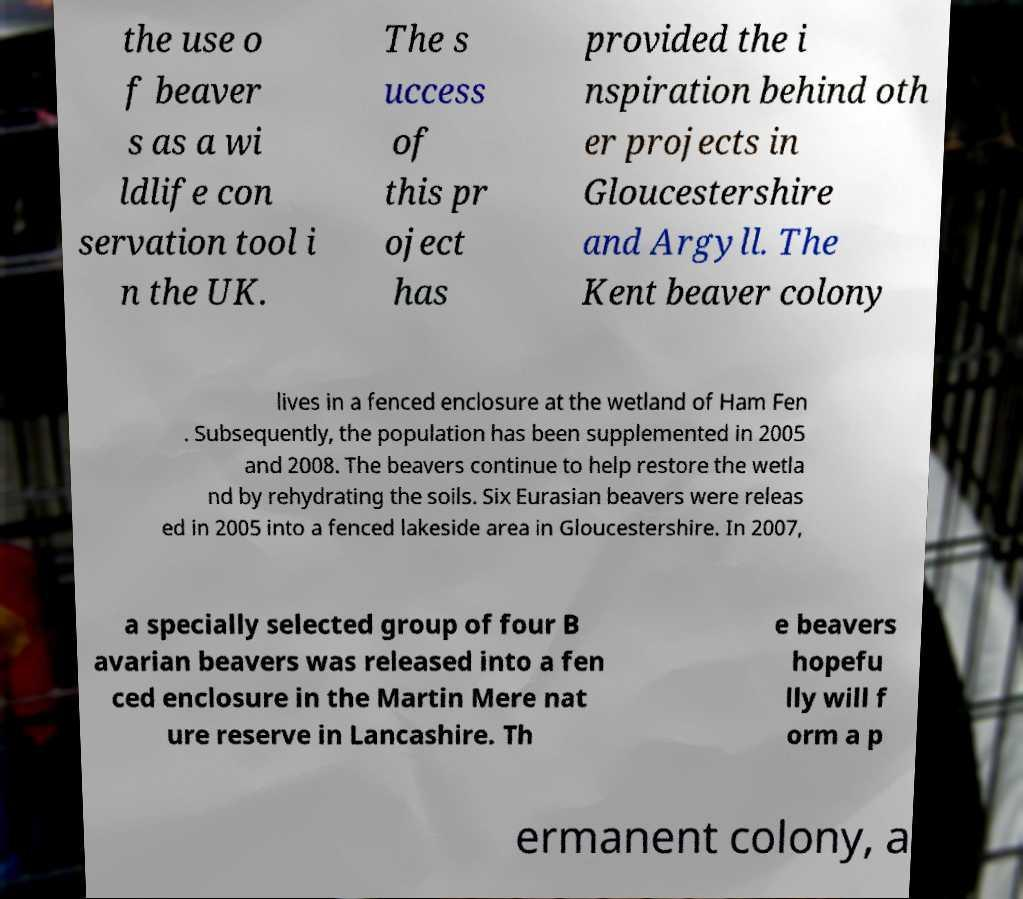What messages or text are displayed in this image? I need them in a readable, typed format. the use o f beaver s as a wi ldlife con servation tool i n the UK. The s uccess of this pr oject has provided the i nspiration behind oth er projects in Gloucestershire and Argyll. The Kent beaver colony lives in a fenced enclosure at the wetland of Ham Fen . Subsequently, the population has been supplemented in 2005 and 2008. The beavers continue to help restore the wetla nd by rehydrating the soils. Six Eurasian beavers were releas ed in 2005 into a fenced lakeside area in Gloucestershire. In 2007, a specially selected group of four B avarian beavers was released into a fen ced enclosure in the Martin Mere nat ure reserve in Lancashire. Th e beavers hopefu lly will f orm a p ermanent colony, a 